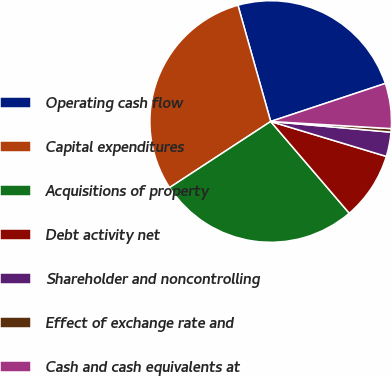<chart> <loc_0><loc_0><loc_500><loc_500><pie_chart><fcel>Operating cash flow<fcel>Capital expenditures<fcel>Acquisitions of property<fcel>Debt activity net<fcel>Shareholder and noncontrolling<fcel>Effect of exchange rate and<fcel>Cash and cash equivalents at<nl><fcel>24.27%<fcel>29.85%<fcel>27.06%<fcel>9.06%<fcel>3.26%<fcel>0.47%<fcel>6.04%<nl></chart> 